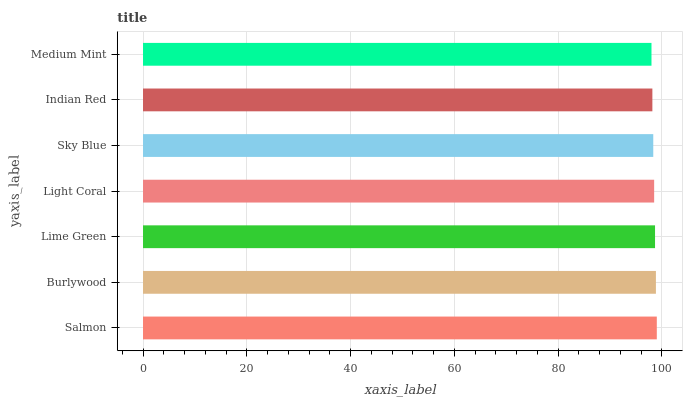Is Medium Mint the minimum?
Answer yes or no. Yes. Is Salmon the maximum?
Answer yes or no. Yes. Is Burlywood the minimum?
Answer yes or no. No. Is Burlywood the maximum?
Answer yes or no. No. Is Salmon greater than Burlywood?
Answer yes or no. Yes. Is Burlywood less than Salmon?
Answer yes or no. Yes. Is Burlywood greater than Salmon?
Answer yes or no. No. Is Salmon less than Burlywood?
Answer yes or no. No. Is Light Coral the high median?
Answer yes or no. Yes. Is Light Coral the low median?
Answer yes or no. Yes. Is Lime Green the high median?
Answer yes or no. No. Is Sky Blue the low median?
Answer yes or no. No. 